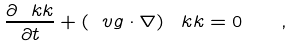Convert formula to latex. <formula><loc_0><loc_0><loc_500><loc_500>\frac { \partial \ k k } { \partial t } + \left ( \ v g \cdot \nabla \right ) \ k k = 0 \quad ,</formula> 